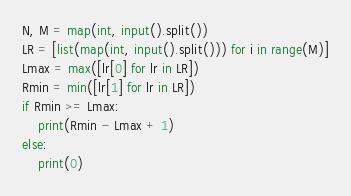<code> <loc_0><loc_0><loc_500><loc_500><_Python_>N, M = map(int, input().split())
LR = [list(map(int, input().split())) for i in range(M)]
Lmax = max([lr[0] for lr in LR])
Rmin = min([lr[1] for lr in LR])
if Rmin >= Lmax:
    print(Rmin - Lmax + 1)
else:
    print(0)
</code> 